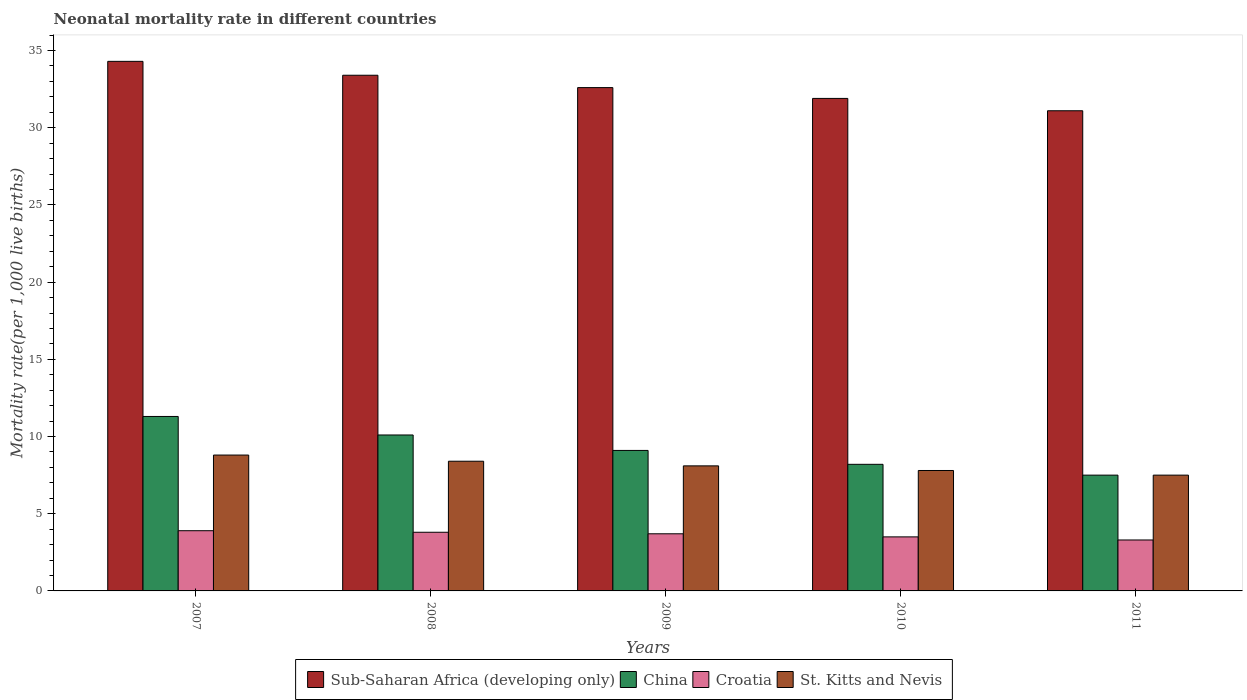Are the number of bars per tick equal to the number of legend labels?
Offer a very short reply. Yes. How many bars are there on the 4th tick from the right?
Your response must be concise. 4. What is the neonatal mortality rate in China in 2011?
Offer a terse response. 7.5. Across all years, what is the maximum neonatal mortality rate in China?
Provide a short and direct response. 11.3. Across all years, what is the minimum neonatal mortality rate in Sub-Saharan Africa (developing only)?
Ensure brevity in your answer.  31.1. In which year was the neonatal mortality rate in Sub-Saharan Africa (developing only) minimum?
Offer a terse response. 2011. What is the total neonatal mortality rate in Sub-Saharan Africa (developing only) in the graph?
Your answer should be compact. 163.3. What is the difference between the neonatal mortality rate in Croatia in 2007 and the neonatal mortality rate in China in 2008?
Offer a very short reply. -6.2. What is the average neonatal mortality rate in Croatia per year?
Provide a short and direct response. 3.64. In the year 2008, what is the difference between the neonatal mortality rate in Sub-Saharan Africa (developing only) and neonatal mortality rate in St. Kitts and Nevis?
Your response must be concise. 25. In how many years, is the neonatal mortality rate in St. Kitts and Nevis greater than 15?
Your answer should be compact. 0. What is the ratio of the neonatal mortality rate in Sub-Saharan Africa (developing only) in 2010 to that in 2011?
Provide a succinct answer. 1.03. Is the neonatal mortality rate in Croatia in 2007 less than that in 2008?
Provide a succinct answer. No. What is the difference between the highest and the second highest neonatal mortality rate in St. Kitts and Nevis?
Ensure brevity in your answer.  0.4. What is the difference between the highest and the lowest neonatal mortality rate in Croatia?
Make the answer very short. 0.6. In how many years, is the neonatal mortality rate in Sub-Saharan Africa (developing only) greater than the average neonatal mortality rate in Sub-Saharan Africa (developing only) taken over all years?
Offer a terse response. 2. Is the sum of the neonatal mortality rate in Croatia in 2008 and 2009 greater than the maximum neonatal mortality rate in St. Kitts and Nevis across all years?
Your answer should be compact. No. Is it the case that in every year, the sum of the neonatal mortality rate in St. Kitts and Nevis and neonatal mortality rate in Sub-Saharan Africa (developing only) is greater than the sum of neonatal mortality rate in China and neonatal mortality rate in Croatia?
Provide a succinct answer. Yes. What does the 4th bar from the right in 2009 represents?
Provide a short and direct response. Sub-Saharan Africa (developing only). Is it the case that in every year, the sum of the neonatal mortality rate in Sub-Saharan Africa (developing only) and neonatal mortality rate in St. Kitts and Nevis is greater than the neonatal mortality rate in Croatia?
Your answer should be compact. Yes. How many bars are there?
Keep it short and to the point. 20. Are all the bars in the graph horizontal?
Ensure brevity in your answer.  No. What is the difference between two consecutive major ticks on the Y-axis?
Offer a terse response. 5. Are the values on the major ticks of Y-axis written in scientific E-notation?
Give a very brief answer. No. Does the graph contain grids?
Keep it short and to the point. No. Where does the legend appear in the graph?
Offer a very short reply. Bottom center. How many legend labels are there?
Your answer should be compact. 4. How are the legend labels stacked?
Provide a short and direct response. Horizontal. What is the title of the graph?
Offer a very short reply. Neonatal mortality rate in different countries. Does "Congo (Republic)" appear as one of the legend labels in the graph?
Give a very brief answer. No. What is the label or title of the X-axis?
Your answer should be very brief. Years. What is the label or title of the Y-axis?
Provide a short and direct response. Mortality rate(per 1,0 live births). What is the Mortality rate(per 1,000 live births) of Sub-Saharan Africa (developing only) in 2007?
Your answer should be compact. 34.3. What is the Mortality rate(per 1,000 live births) of Sub-Saharan Africa (developing only) in 2008?
Offer a terse response. 33.4. What is the Mortality rate(per 1,000 live births) of Sub-Saharan Africa (developing only) in 2009?
Your response must be concise. 32.6. What is the Mortality rate(per 1,000 live births) of China in 2009?
Provide a short and direct response. 9.1. What is the Mortality rate(per 1,000 live births) in St. Kitts and Nevis in 2009?
Your response must be concise. 8.1. What is the Mortality rate(per 1,000 live births) of Sub-Saharan Africa (developing only) in 2010?
Offer a very short reply. 31.9. What is the Mortality rate(per 1,000 live births) of Croatia in 2010?
Provide a short and direct response. 3.5. What is the Mortality rate(per 1,000 live births) of St. Kitts and Nevis in 2010?
Offer a terse response. 7.8. What is the Mortality rate(per 1,000 live births) of Sub-Saharan Africa (developing only) in 2011?
Offer a very short reply. 31.1. What is the Mortality rate(per 1,000 live births) of St. Kitts and Nevis in 2011?
Make the answer very short. 7.5. Across all years, what is the maximum Mortality rate(per 1,000 live births) of Sub-Saharan Africa (developing only)?
Offer a terse response. 34.3. Across all years, what is the maximum Mortality rate(per 1,000 live births) in China?
Ensure brevity in your answer.  11.3. Across all years, what is the maximum Mortality rate(per 1,000 live births) in St. Kitts and Nevis?
Give a very brief answer. 8.8. Across all years, what is the minimum Mortality rate(per 1,000 live births) of Sub-Saharan Africa (developing only)?
Provide a short and direct response. 31.1. What is the total Mortality rate(per 1,000 live births) of Sub-Saharan Africa (developing only) in the graph?
Offer a very short reply. 163.3. What is the total Mortality rate(per 1,000 live births) of China in the graph?
Offer a very short reply. 46.2. What is the total Mortality rate(per 1,000 live births) in Croatia in the graph?
Your answer should be compact. 18.2. What is the total Mortality rate(per 1,000 live births) in St. Kitts and Nevis in the graph?
Offer a very short reply. 40.6. What is the difference between the Mortality rate(per 1,000 live births) in Sub-Saharan Africa (developing only) in 2007 and that in 2008?
Your answer should be compact. 0.9. What is the difference between the Mortality rate(per 1,000 live births) in China in 2007 and that in 2008?
Give a very brief answer. 1.2. What is the difference between the Mortality rate(per 1,000 live births) of St. Kitts and Nevis in 2007 and that in 2008?
Keep it short and to the point. 0.4. What is the difference between the Mortality rate(per 1,000 live births) in Sub-Saharan Africa (developing only) in 2007 and that in 2009?
Your response must be concise. 1.7. What is the difference between the Mortality rate(per 1,000 live births) in China in 2007 and that in 2009?
Offer a terse response. 2.2. What is the difference between the Mortality rate(per 1,000 live births) in Croatia in 2007 and that in 2009?
Your answer should be compact. 0.2. What is the difference between the Mortality rate(per 1,000 live births) in Sub-Saharan Africa (developing only) in 2007 and that in 2010?
Your answer should be very brief. 2.4. What is the difference between the Mortality rate(per 1,000 live births) in Croatia in 2007 and that in 2010?
Provide a short and direct response. 0.4. What is the difference between the Mortality rate(per 1,000 live births) of China in 2007 and that in 2011?
Provide a short and direct response. 3.8. What is the difference between the Mortality rate(per 1,000 live births) in Croatia in 2007 and that in 2011?
Give a very brief answer. 0.6. What is the difference between the Mortality rate(per 1,000 live births) in St. Kitts and Nevis in 2007 and that in 2011?
Your answer should be very brief. 1.3. What is the difference between the Mortality rate(per 1,000 live births) of Croatia in 2008 and that in 2010?
Make the answer very short. 0.3. What is the difference between the Mortality rate(per 1,000 live births) in China in 2008 and that in 2011?
Keep it short and to the point. 2.6. What is the difference between the Mortality rate(per 1,000 live births) of Croatia in 2008 and that in 2011?
Make the answer very short. 0.5. What is the difference between the Mortality rate(per 1,000 live births) of China in 2009 and that in 2010?
Give a very brief answer. 0.9. What is the difference between the Mortality rate(per 1,000 live births) in China in 2009 and that in 2011?
Your response must be concise. 1.6. What is the difference between the Mortality rate(per 1,000 live births) of Croatia in 2009 and that in 2011?
Make the answer very short. 0.4. What is the difference between the Mortality rate(per 1,000 live births) of China in 2010 and that in 2011?
Provide a short and direct response. 0.7. What is the difference between the Mortality rate(per 1,000 live births) of Croatia in 2010 and that in 2011?
Offer a terse response. 0.2. What is the difference between the Mortality rate(per 1,000 live births) of St. Kitts and Nevis in 2010 and that in 2011?
Give a very brief answer. 0.3. What is the difference between the Mortality rate(per 1,000 live births) of Sub-Saharan Africa (developing only) in 2007 and the Mortality rate(per 1,000 live births) of China in 2008?
Your answer should be compact. 24.2. What is the difference between the Mortality rate(per 1,000 live births) of Sub-Saharan Africa (developing only) in 2007 and the Mortality rate(per 1,000 live births) of Croatia in 2008?
Provide a short and direct response. 30.5. What is the difference between the Mortality rate(per 1,000 live births) of Sub-Saharan Africa (developing only) in 2007 and the Mortality rate(per 1,000 live births) of St. Kitts and Nevis in 2008?
Offer a terse response. 25.9. What is the difference between the Mortality rate(per 1,000 live births) in Sub-Saharan Africa (developing only) in 2007 and the Mortality rate(per 1,000 live births) in China in 2009?
Provide a succinct answer. 25.2. What is the difference between the Mortality rate(per 1,000 live births) in Sub-Saharan Africa (developing only) in 2007 and the Mortality rate(per 1,000 live births) in Croatia in 2009?
Make the answer very short. 30.6. What is the difference between the Mortality rate(per 1,000 live births) in Sub-Saharan Africa (developing only) in 2007 and the Mortality rate(per 1,000 live births) in St. Kitts and Nevis in 2009?
Keep it short and to the point. 26.2. What is the difference between the Mortality rate(per 1,000 live births) in Croatia in 2007 and the Mortality rate(per 1,000 live births) in St. Kitts and Nevis in 2009?
Keep it short and to the point. -4.2. What is the difference between the Mortality rate(per 1,000 live births) of Sub-Saharan Africa (developing only) in 2007 and the Mortality rate(per 1,000 live births) of China in 2010?
Keep it short and to the point. 26.1. What is the difference between the Mortality rate(per 1,000 live births) in Sub-Saharan Africa (developing only) in 2007 and the Mortality rate(per 1,000 live births) in Croatia in 2010?
Keep it short and to the point. 30.8. What is the difference between the Mortality rate(per 1,000 live births) of China in 2007 and the Mortality rate(per 1,000 live births) of Croatia in 2010?
Your answer should be very brief. 7.8. What is the difference between the Mortality rate(per 1,000 live births) in Sub-Saharan Africa (developing only) in 2007 and the Mortality rate(per 1,000 live births) in China in 2011?
Your answer should be compact. 26.8. What is the difference between the Mortality rate(per 1,000 live births) in Sub-Saharan Africa (developing only) in 2007 and the Mortality rate(per 1,000 live births) in St. Kitts and Nevis in 2011?
Your answer should be very brief. 26.8. What is the difference between the Mortality rate(per 1,000 live births) in Sub-Saharan Africa (developing only) in 2008 and the Mortality rate(per 1,000 live births) in China in 2009?
Offer a very short reply. 24.3. What is the difference between the Mortality rate(per 1,000 live births) in Sub-Saharan Africa (developing only) in 2008 and the Mortality rate(per 1,000 live births) in Croatia in 2009?
Make the answer very short. 29.7. What is the difference between the Mortality rate(per 1,000 live births) of Sub-Saharan Africa (developing only) in 2008 and the Mortality rate(per 1,000 live births) of St. Kitts and Nevis in 2009?
Ensure brevity in your answer.  25.3. What is the difference between the Mortality rate(per 1,000 live births) of Croatia in 2008 and the Mortality rate(per 1,000 live births) of St. Kitts and Nevis in 2009?
Provide a succinct answer. -4.3. What is the difference between the Mortality rate(per 1,000 live births) of Sub-Saharan Africa (developing only) in 2008 and the Mortality rate(per 1,000 live births) of China in 2010?
Offer a terse response. 25.2. What is the difference between the Mortality rate(per 1,000 live births) of Sub-Saharan Africa (developing only) in 2008 and the Mortality rate(per 1,000 live births) of Croatia in 2010?
Keep it short and to the point. 29.9. What is the difference between the Mortality rate(per 1,000 live births) of Sub-Saharan Africa (developing only) in 2008 and the Mortality rate(per 1,000 live births) of St. Kitts and Nevis in 2010?
Offer a terse response. 25.6. What is the difference between the Mortality rate(per 1,000 live births) in Croatia in 2008 and the Mortality rate(per 1,000 live births) in St. Kitts and Nevis in 2010?
Make the answer very short. -4. What is the difference between the Mortality rate(per 1,000 live births) in Sub-Saharan Africa (developing only) in 2008 and the Mortality rate(per 1,000 live births) in China in 2011?
Keep it short and to the point. 25.9. What is the difference between the Mortality rate(per 1,000 live births) in Sub-Saharan Africa (developing only) in 2008 and the Mortality rate(per 1,000 live births) in Croatia in 2011?
Offer a terse response. 30.1. What is the difference between the Mortality rate(per 1,000 live births) of Sub-Saharan Africa (developing only) in 2008 and the Mortality rate(per 1,000 live births) of St. Kitts and Nevis in 2011?
Your response must be concise. 25.9. What is the difference between the Mortality rate(per 1,000 live births) of China in 2008 and the Mortality rate(per 1,000 live births) of Croatia in 2011?
Your response must be concise. 6.8. What is the difference between the Mortality rate(per 1,000 live births) in China in 2008 and the Mortality rate(per 1,000 live births) in St. Kitts and Nevis in 2011?
Keep it short and to the point. 2.6. What is the difference between the Mortality rate(per 1,000 live births) in Croatia in 2008 and the Mortality rate(per 1,000 live births) in St. Kitts and Nevis in 2011?
Your answer should be very brief. -3.7. What is the difference between the Mortality rate(per 1,000 live births) of Sub-Saharan Africa (developing only) in 2009 and the Mortality rate(per 1,000 live births) of China in 2010?
Your response must be concise. 24.4. What is the difference between the Mortality rate(per 1,000 live births) of Sub-Saharan Africa (developing only) in 2009 and the Mortality rate(per 1,000 live births) of Croatia in 2010?
Offer a terse response. 29.1. What is the difference between the Mortality rate(per 1,000 live births) of Sub-Saharan Africa (developing only) in 2009 and the Mortality rate(per 1,000 live births) of St. Kitts and Nevis in 2010?
Give a very brief answer. 24.8. What is the difference between the Mortality rate(per 1,000 live births) of China in 2009 and the Mortality rate(per 1,000 live births) of St. Kitts and Nevis in 2010?
Give a very brief answer. 1.3. What is the difference between the Mortality rate(per 1,000 live births) of Sub-Saharan Africa (developing only) in 2009 and the Mortality rate(per 1,000 live births) of China in 2011?
Keep it short and to the point. 25.1. What is the difference between the Mortality rate(per 1,000 live births) in Sub-Saharan Africa (developing only) in 2009 and the Mortality rate(per 1,000 live births) in Croatia in 2011?
Offer a terse response. 29.3. What is the difference between the Mortality rate(per 1,000 live births) in Sub-Saharan Africa (developing only) in 2009 and the Mortality rate(per 1,000 live births) in St. Kitts and Nevis in 2011?
Ensure brevity in your answer.  25.1. What is the difference between the Mortality rate(per 1,000 live births) of Sub-Saharan Africa (developing only) in 2010 and the Mortality rate(per 1,000 live births) of China in 2011?
Provide a succinct answer. 24.4. What is the difference between the Mortality rate(per 1,000 live births) in Sub-Saharan Africa (developing only) in 2010 and the Mortality rate(per 1,000 live births) in Croatia in 2011?
Provide a succinct answer. 28.6. What is the difference between the Mortality rate(per 1,000 live births) of Sub-Saharan Africa (developing only) in 2010 and the Mortality rate(per 1,000 live births) of St. Kitts and Nevis in 2011?
Provide a short and direct response. 24.4. What is the difference between the Mortality rate(per 1,000 live births) in China in 2010 and the Mortality rate(per 1,000 live births) in St. Kitts and Nevis in 2011?
Offer a very short reply. 0.7. What is the difference between the Mortality rate(per 1,000 live births) of Croatia in 2010 and the Mortality rate(per 1,000 live births) of St. Kitts and Nevis in 2011?
Your answer should be compact. -4. What is the average Mortality rate(per 1,000 live births) of Sub-Saharan Africa (developing only) per year?
Make the answer very short. 32.66. What is the average Mortality rate(per 1,000 live births) of China per year?
Keep it short and to the point. 9.24. What is the average Mortality rate(per 1,000 live births) of Croatia per year?
Make the answer very short. 3.64. What is the average Mortality rate(per 1,000 live births) of St. Kitts and Nevis per year?
Make the answer very short. 8.12. In the year 2007, what is the difference between the Mortality rate(per 1,000 live births) in Sub-Saharan Africa (developing only) and Mortality rate(per 1,000 live births) in China?
Make the answer very short. 23. In the year 2007, what is the difference between the Mortality rate(per 1,000 live births) in Sub-Saharan Africa (developing only) and Mortality rate(per 1,000 live births) in Croatia?
Offer a very short reply. 30.4. In the year 2007, what is the difference between the Mortality rate(per 1,000 live births) of China and Mortality rate(per 1,000 live births) of Croatia?
Your response must be concise. 7.4. In the year 2007, what is the difference between the Mortality rate(per 1,000 live births) in Croatia and Mortality rate(per 1,000 live births) in St. Kitts and Nevis?
Offer a very short reply. -4.9. In the year 2008, what is the difference between the Mortality rate(per 1,000 live births) in Sub-Saharan Africa (developing only) and Mortality rate(per 1,000 live births) in China?
Your answer should be compact. 23.3. In the year 2008, what is the difference between the Mortality rate(per 1,000 live births) in Sub-Saharan Africa (developing only) and Mortality rate(per 1,000 live births) in Croatia?
Your answer should be compact. 29.6. In the year 2008, what is the difference between the Mortality rate(per 1,000 live births) in Sub-Saharan Africa (developing only) and Mortality rate(per 1,000 live births) in St. Kitts and Nevis?
Offer a terse response. 25. In the year 2008, what is the difference between the Mortality rate(per 1,000 live births) of China and Mortality rate(per 1,000 live births) of Croatia?
Your answer should be very brief. 6.3. In the year 2009, what is the difference between the Mortality rate(per 1,000 live births) of Sub-Saharan Africa (developing only) and Mortality rate(per 1,000 live births) of Croatia?
Make the answer very short. 28.9. In the year 2009, what is the difference between the Mortality rate(per 1,000 live births) of China and Mortality rate(per 1,000 live births) of St. Kitts and Nevis?
Your answer should be compact. 1. In the year 2009, what is the difference between the Mortality rate(per 1,000 live births) of Croatia and Mortality rate(per 1,000 live births) of St. Kitts and Nevis?
Offer a very short reply. -4.4. In the year 2010, what is the difference between the Mortality rate(per 1,000 live births) in Sub-Saharan Africa (developing only) and Mortality rate(per 1,000 live births) in China?
Offer a terse response. 23.7. In the year 2010, what is the difference between the Mortality rate(per 1,000 live births) in Sub-Saharan Africa (developing only) and Mortality rate(per 1,000 live births) in Croatia?
Provide a succinct answer. 28.4. In the year 2010, what is the difference between the Mortality rate(per 1,000 live births) of Sub-Saharan Africa (developing only) and Mortality rate(per 1,000 live births) of St. Kitts and Nevis?
Your response must be concise. 24.1. In the year 2010, what is the difference between the Mortality rate(per 1,000 live births) of Croatia and Mortality rate(per 1,000 live births) of St. Kitts and Nevis?
Offer a very short reply. -4.3. In the year 2011, what is the difference between the Mortality rate(per 1,000 live births) of Sub-Saharan Africa (developing only) and Mortality rate(per 1,000 live births) of China?
Offer a terse response. 23.6. In the year 2011, what is the difference between the Mortality rate(per 1,000 live births) of Sub-Saharan Africa (developing only) and Mortality rate(per 1,000 live births) of Croatia?
Provide a succinct answer. 27.8. In the year 2011, what is the difference between the Mortality rate(per 1,000 live births) of Sub-Saharan Africa (developing only) and Mortality rate(per 1,000 live births) of St. Kitts and Nevis?
Make the answer very short. 23.6. In the year 2011, what is the difference between the Mortality rate(per 1,000 live births) of Croatia and Mortality rate(per 1,000 live births) of St. Kitts and Nevis?
Keep it short and to the point. -4.2. What is the ratio of the Mortality rate(per 1,000 live births) of Sub-Saharan Africa (developing only) in 2007 to that in 2008?
Make the answer very short. 1.03. What is the ratio of the Mortality rate(per 1,000 live births) in China in 2007 to that in 2008?
Your response must be concise. 1.12. What is the ratio of the Mortality rate(per 1,000 live births) of Croatia in 2007 to that in 2008?
Your answer should be compact. 1.03. What is the ratio of the Mortality rate(per 1,000 live births) in St. Kitts and Nevis in 2007 to that in 2008?
Provide a succinct answer. 1.05. What is the ratio of the Mortality rate(per 1,000 live births) in Sub-Saharan Africa (developing only) in 2007 to that in 2009?
Your response must be concise. 1.05. What is the ratio of the Mortality rate(per 1,000 live births) of China in 2007 to that in 2009?
Keep it short and to the point. 1.24. What is the ratio of the Mortality rate(per 1,000 live births) in Croatia in 2007 to that in 2009?
Offer a very short reply. 1.05. What is the ratio of the Mortality rate(per 1,000 live births) in St. Kitts and Nevis in 2007 to that in 2009?
Give a very brief answer. 1.09. What is the ratio of the Mortality rate(per 1,000 live births) of Sub-Saharan Africa (developing only) in 2007 to that in 2010?
Ensure brevity in your answer.  1.08. What is the ratio of the Mortality rate(per 1,000 live births) of China in 2007 to that in 2010?
Give a very brief answer. 1.38. What is the ratio of the Mortality rate(per 1,000 live births) of Croatia in 2007 to that in 2010?
Ensure brevity in your answer.  1.11. What is the ratio of the Mortality rate(per 1,000 live births) in St. Kitts and Nevis in 2007 to that in 2010?
Your answer should be compact. 1.13. What is the ratio of the Mortality rate(per 1,000 live births) in Sub-Saharan Africa (developing only) in 2007 to that in 2011?
Your answer should be very brief. 1.1. What is the ratio of the Mortality rate(per 1,000 live births) of China in 2007 to that in 2011?
Give a very brief answer. 1.51. What is the ratio of the Mortality rate(per 1,000 live births) of Croatia in 2007 to that in 2011?
Keep it short and to the point. 1.18. What is the ratio of the Mortality rate(per 1,000 live births) of St. Kitts and Nevis in 2007 to that in 2011?
Provide a succinct answer. 1.17. What is the ratio of the Mortality rate(per 1,000 live births) of Sub-Saharan Africa (developing only) in 2008 to that in 2009?
Offer a very short reply. 1.02. What is the ratio of the Mortality rate(per 1,000 live births) of China in 2008 to that in 2009?
Your response must be concise. 1.11. What is the ratio of the Mortality rate(per 1,000 live births) in Croatia in 2008 to that in 2009?
Make the answer very short. 1.03. What is the ratio of the Mortality rate(per 1,000 live births) in St. Kitts and Nevis in 2008 to that in 2009?
Make the answer very short. 1.04. What is the ratio of the Mortality rate(per 1,000 live births) of Sub-Saharan Africa (developing only) in 2008 to that in 2010?
Make the answer very short. 1.05. What is the ratio of the Mortality rate(per 1,000 live births) in China in 2008 to that in 2010?
Provide a succinct answer. 1.23. What is the ratio of the Mortality rate(per 1,000 live births) of Croatia in 2008 to that in 2010?
Give a very brief answer. 1.09. What is the ratio of the Mortality rate(per 1,000 live births) in St. Kitts and Nevis in 2008 to that in 2010?
Offer a very short reply. 1.08. What is the ratio of the Mortality rate(per 1,000 live births) of Sub-Saharan Africa (developing only) in 2008 to that in 2011?
Give a very brief answer. 1.07. What is the ratio of the Mortality rate(per 1,000 live births) of China in 2008 to that in 2011?
Provide a succinct answer. 1.35. What is the ratio of the Mortality rate(per 1,000 live births) in Croatia in 2008 to that in 2011?
Make the answer very short. 1.15. What is the ratio of the Mortality rate(per 1,000 live births) in St. Kitts and Nevis in 2008 to that in 2011?
Provide a succinct answer. 1.12. What is the ratio of the Mortality rate(per 1,000 live births) of Sub-Saharan Africa (developing only) in 2009 to that in 2010?
Offer a terse response. 1.02. What is the ratio of the Mortality rate(per 1,000 live births) in China in 2009 to that in 2010?
Your answer should be compact. 1.11. What is the ratio of the Mortality rate(per 1,000 live births) in Croatia in 2009 to that in 2010?
Ensure brevity in your answer.  1.06. What is the ratio of the Mortality rate(per 1,000 live births) in Sub-Saharan Africa (developing only) in 2009 to that in 2011?
Keep it short and to the point. 1.05. What is the ratio of the Mortality rate(per 1,000 live births) of China in 2009 to that in 2011?
Give a very brief answer. 1.21. What is the ratio of the Mortality rate(per 1,000 live births) of Croatia in 2009 to that in 2011?
Your response must be concise. 1.12. What is the ratio of the Mortality rate(per 1,000 live births) in Sub-Saharan Africa (developing only) in 2010 to that in 2011?
Offer a very short reply. 1.03. What is the ratio of the Mortality rate(per 1,000 live births) of China in 2010 to that in 2011?
Offer a terse response. 1.09. What is the ratio of the Mortality rate(per 1,000 live births) of Croatia in 2010 to that in 2011?
Give a very brief answer. 1.06. What is the difference between the highest and the lowest Mortality rate(per 1,000 live births) of Croatia?
Give a very brief answer. 0.6. 